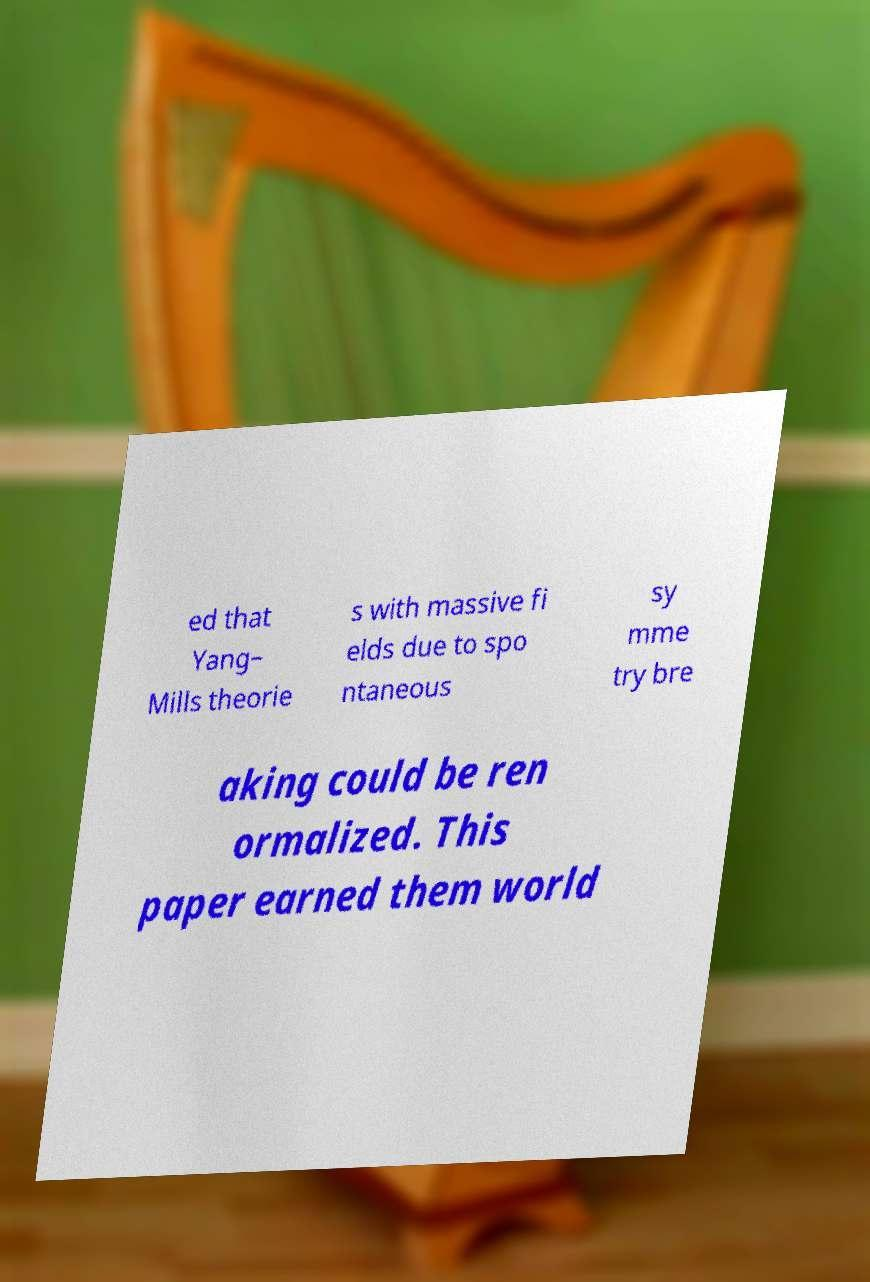Please identify and transcribe the text found in this image. ed that Yang– Mills theorie s with massive fi elds due to spo ntaneous sy mme try bre aking could be ren ormalized. This paper earned them world 